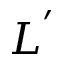<formula> <loc_0><loc_0><loc_500><loc_500>L ^ { ^ { \prime } }</formula> 